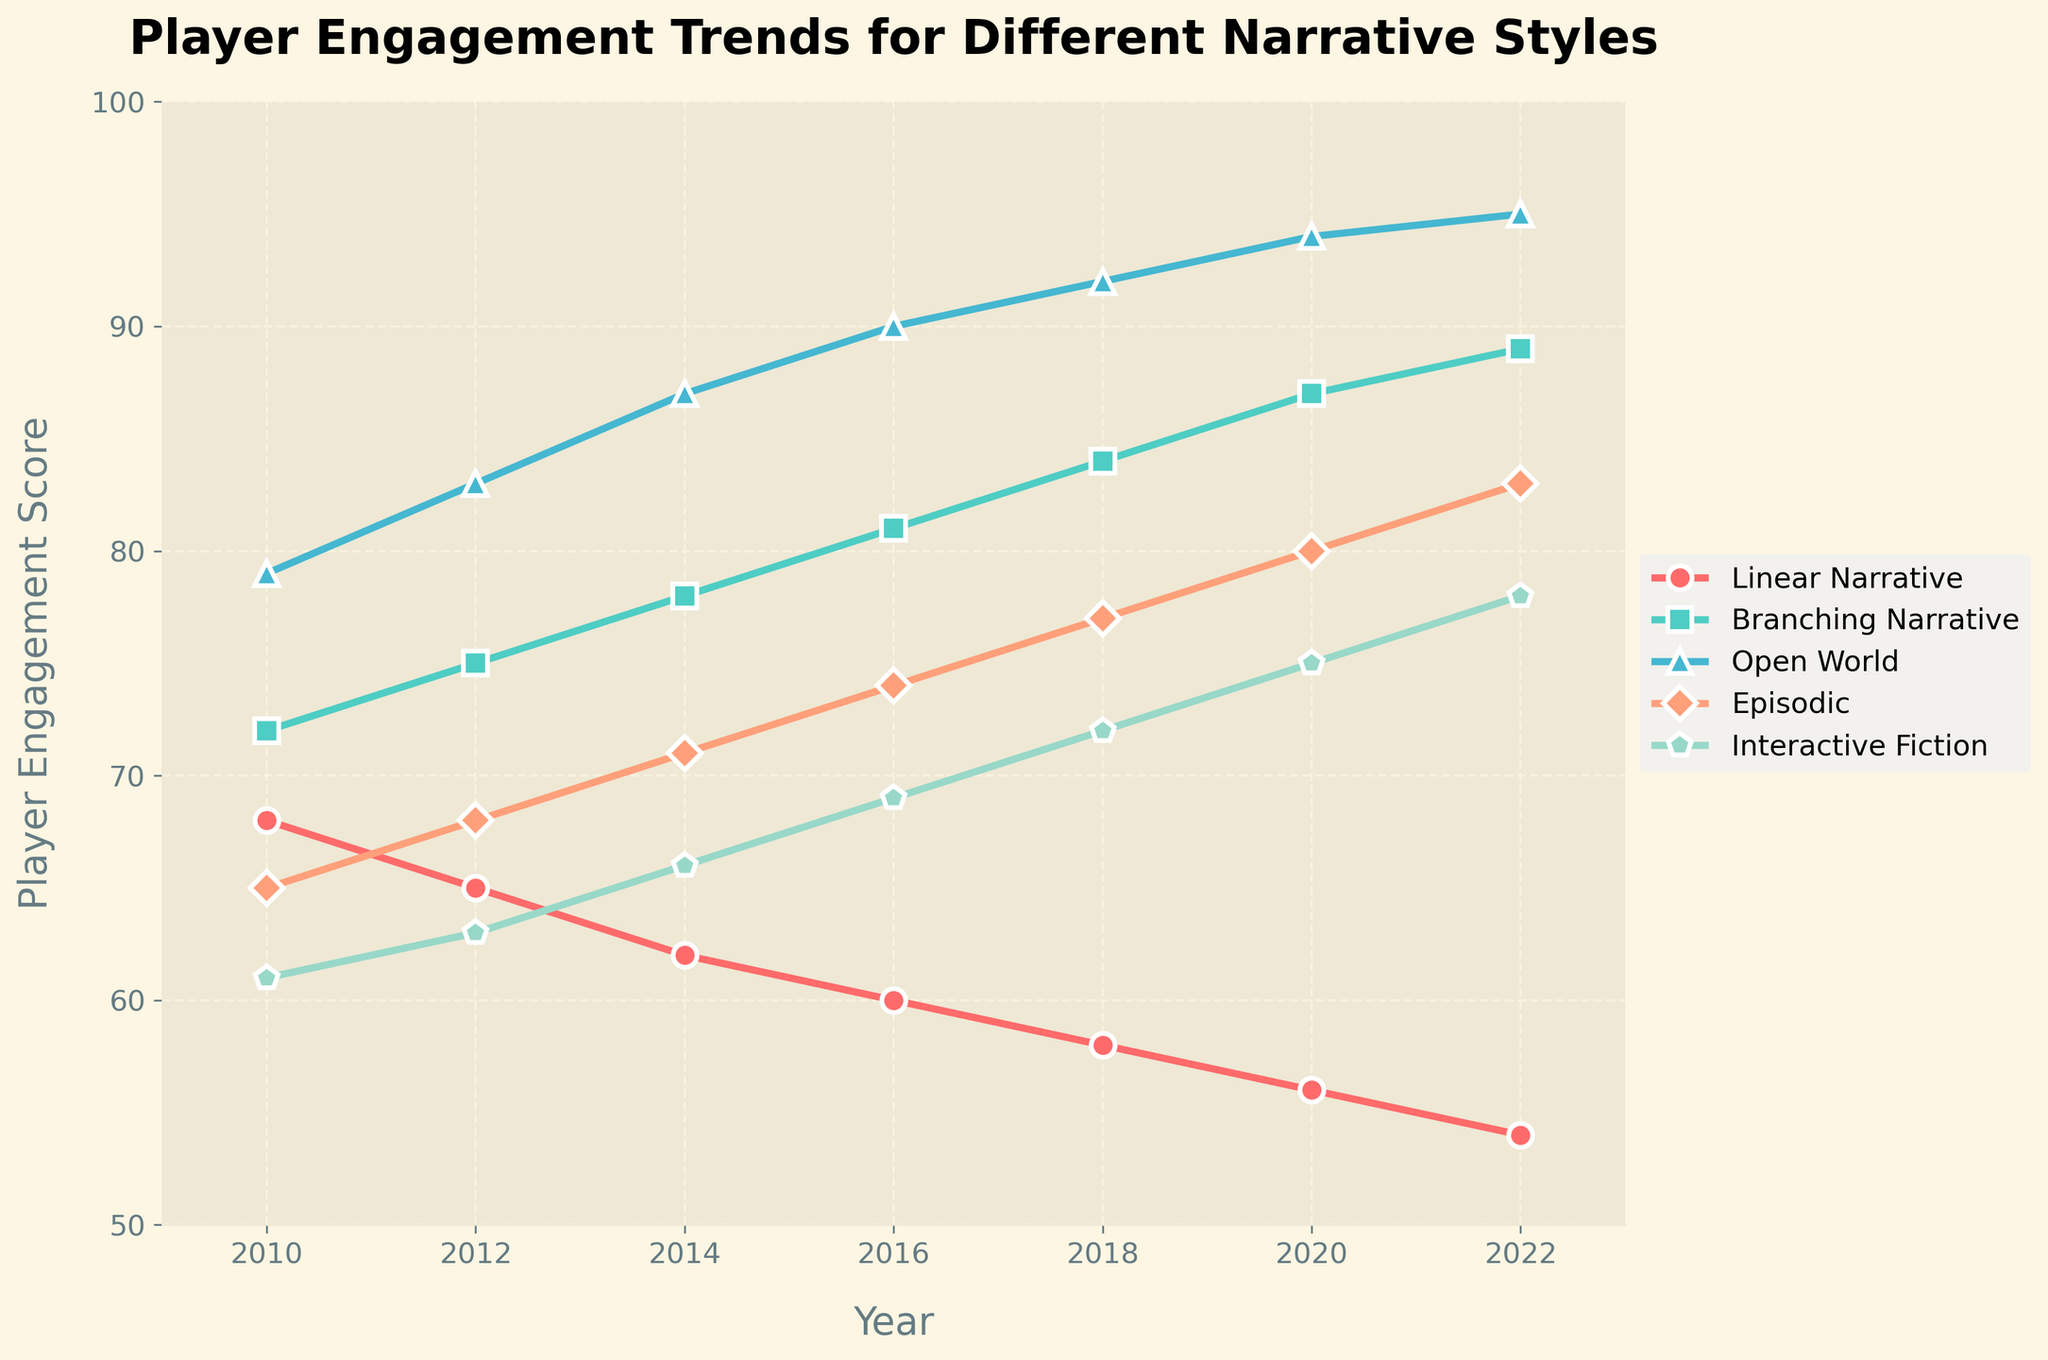What's the trend in player engagement for Open World narrative style between 2010 and 2022? To determine the trend, we observe the player engagement scores for Open World from 2010 to 2022. We see the scores increase from 79 in 2010 to 95 in 2022, indicating a consistent upward trend in player engagement.
Answer: Upward Which narrative style had the highest player engagement score in 2020? By looking at the 2020 data point on the plot for each narrative style, the highest engagement score is for Open World with a score of 94.
Answer: Open World What is the difference in player engagement score between Branching Narrative and Episodic narrative styles in 2014? Refer to the 2014 data points for both Branching Narrative and Episodic. Branching Narrative has a score of 78, while Episodic has 71. The difference is 78 - 71.
Answer: 7 Which narrative style showed the least decline in player engagement from 2010 to 2022? To find the least decline, calculate the difference in scores from 2010 to 2022 for each narrative style. Linear Narrative declined by (68 - 54) = 14, Branching Narrative by (-17), Open World increased, Episodic by (-18), Interactive Fiction by (-17).
Answer: Linear Narrative By how much did player engagement for Interactive Fiction change from 2016 to 2022? Refer to the scores for Interactive Fiction in 2016 (69) and 2022 (78). Compute the change as 78 - 69.
Answer: 9 Compare the player engagement growth rate of Open World to Episodic narratives from 2010 to 2022. Open World increased from 79 to 95, a growth of 16. Episodic increased from 65 to 83, a growth of 18. While both are positive, Episodic had a higher numerical growth.
Answer: Episodic What narrative style consistently improved in engagement score every two years from 2010 to 2022? By following the scores every two years, Open World increased consistently across each time point: 79, 83, 87, 90, 92, 94, 95.
Answer: Open World How does the 2018 engagement score of Branching Narrative compare to Linear Narrative? In 2018, Branching Narrative had a score of 84, and Linear Narrative had 58. Branching Narrative is higher by a difference of 84 - 58.
Answer: 26 higher Which narrative styles have consistently diverging trends from 2010 to 2022? Observe the plot lines for divergent trends. Open World shows an upward trend, while Linear Narrative consistently declines in engagement, indicating diverging trends.
Answer: Open World and Linear Narrative What's the average player engagement score for Episodic narratives across all the years shown? Calculate the sum of Episodic scores from each year (65+68+71+74+77+80+83) = 518, then divide by the total number of years (7).
Answer: 74 